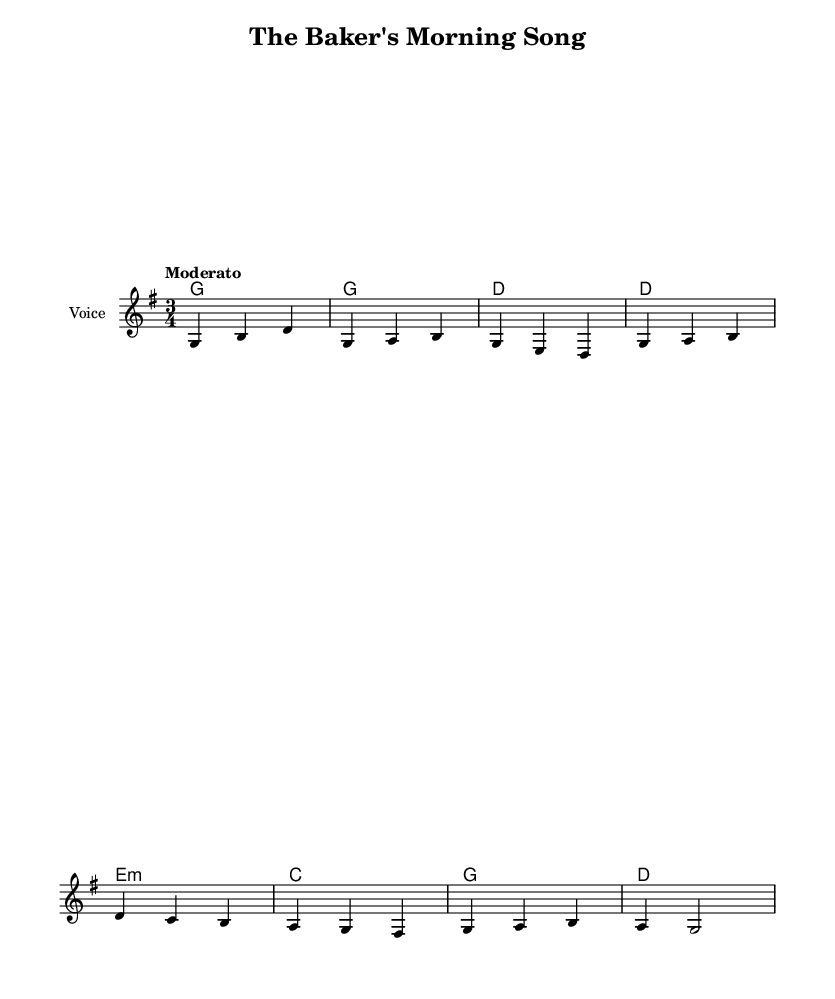What is the key signature of this music? The key signature indicates the music is in G major, which has one sharp (F#).
Answer: G major What is the time signature of this music? The time signature is indicated by the fraction at the beginning of the score, which shows there are three beats per measure and each beat is the length of a quarter note.
Answer: 3/4 What is the tempo marking for this piece? The tempo marking is found at the beginning of the score, stated as "Moderato," which indicates a moderate speed for the piece.
Answer: Moderato How many measures are there in the melody? Counting the individual measures in the provided melody section, there are a total of eight measures.
Answer: 8 Which chord appears first in the harmonies? The first chord in the harmonies section is a G major chord, indicating the root chord of the key.
Answer: G What is the lyrical theme of the ballad? The lyrics reflect the daily life and activities of a baker, particularly focusing on the baking of bread for monks.
Answer: Baking bread What type of song is this? The song is characterized as a folk ballad, which typically tells a story about everyday life or work, highlighting the baker’s craft in this context.
Answer: Folk ballad 